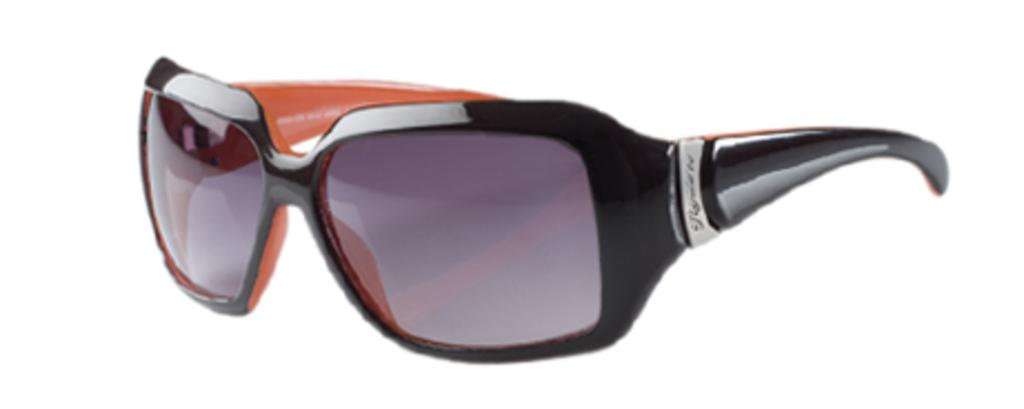What type of eyewear is present in the image? There is a pair of goggles in the image. What might the goggles be used for? The goggles might be used for protection or to enhance vision during activities such as swimming or skiing. Can you tell me how many horses are depicted wearing the goggles in the image? There are no horses present in the image, and therefore no horses wearing goggles. What type of tin can be seen holding the goggles in the image? There is no tin present in the image; the goggles are not being held by any container. 